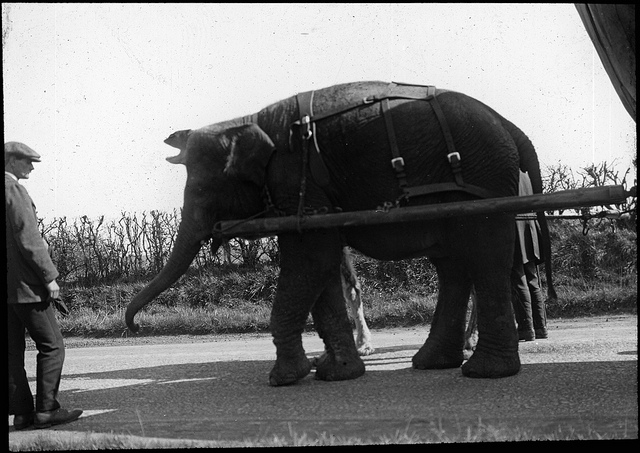<image>What is the contraption on the right? I am unsure what the contraption on the right is, it could be a cart, a trailer, a carriage, a wagon, or a harness. What is the contraption on the right? I don't know what the contraption on the right is. It can be a cart, elephant, wooden stick, trailer, carriage, wagon or harness. 